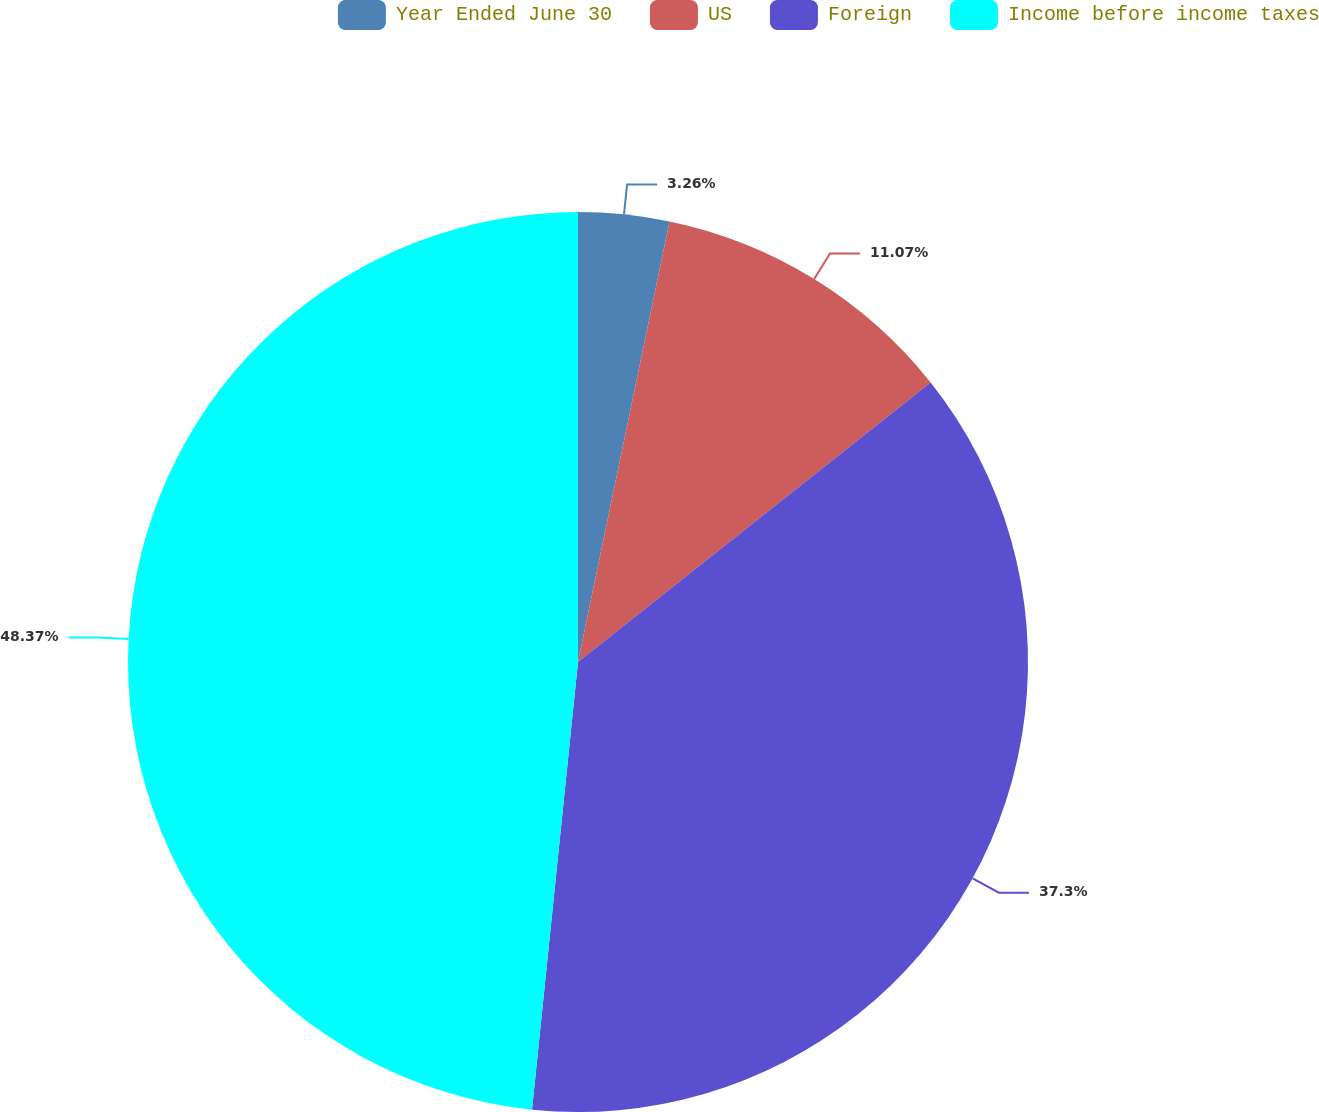Convert chart. <chart><loc_0><loc_0><loc_500><loc_500><pie_chart><fcel>Year Ended June 30<fcel>US<fcel>Foreign<fcel>Income before income taxes<nl><fcel>3.26%<fcel>11.07%<fcel>37.3%<fcel>48.37%<nl></chart> 